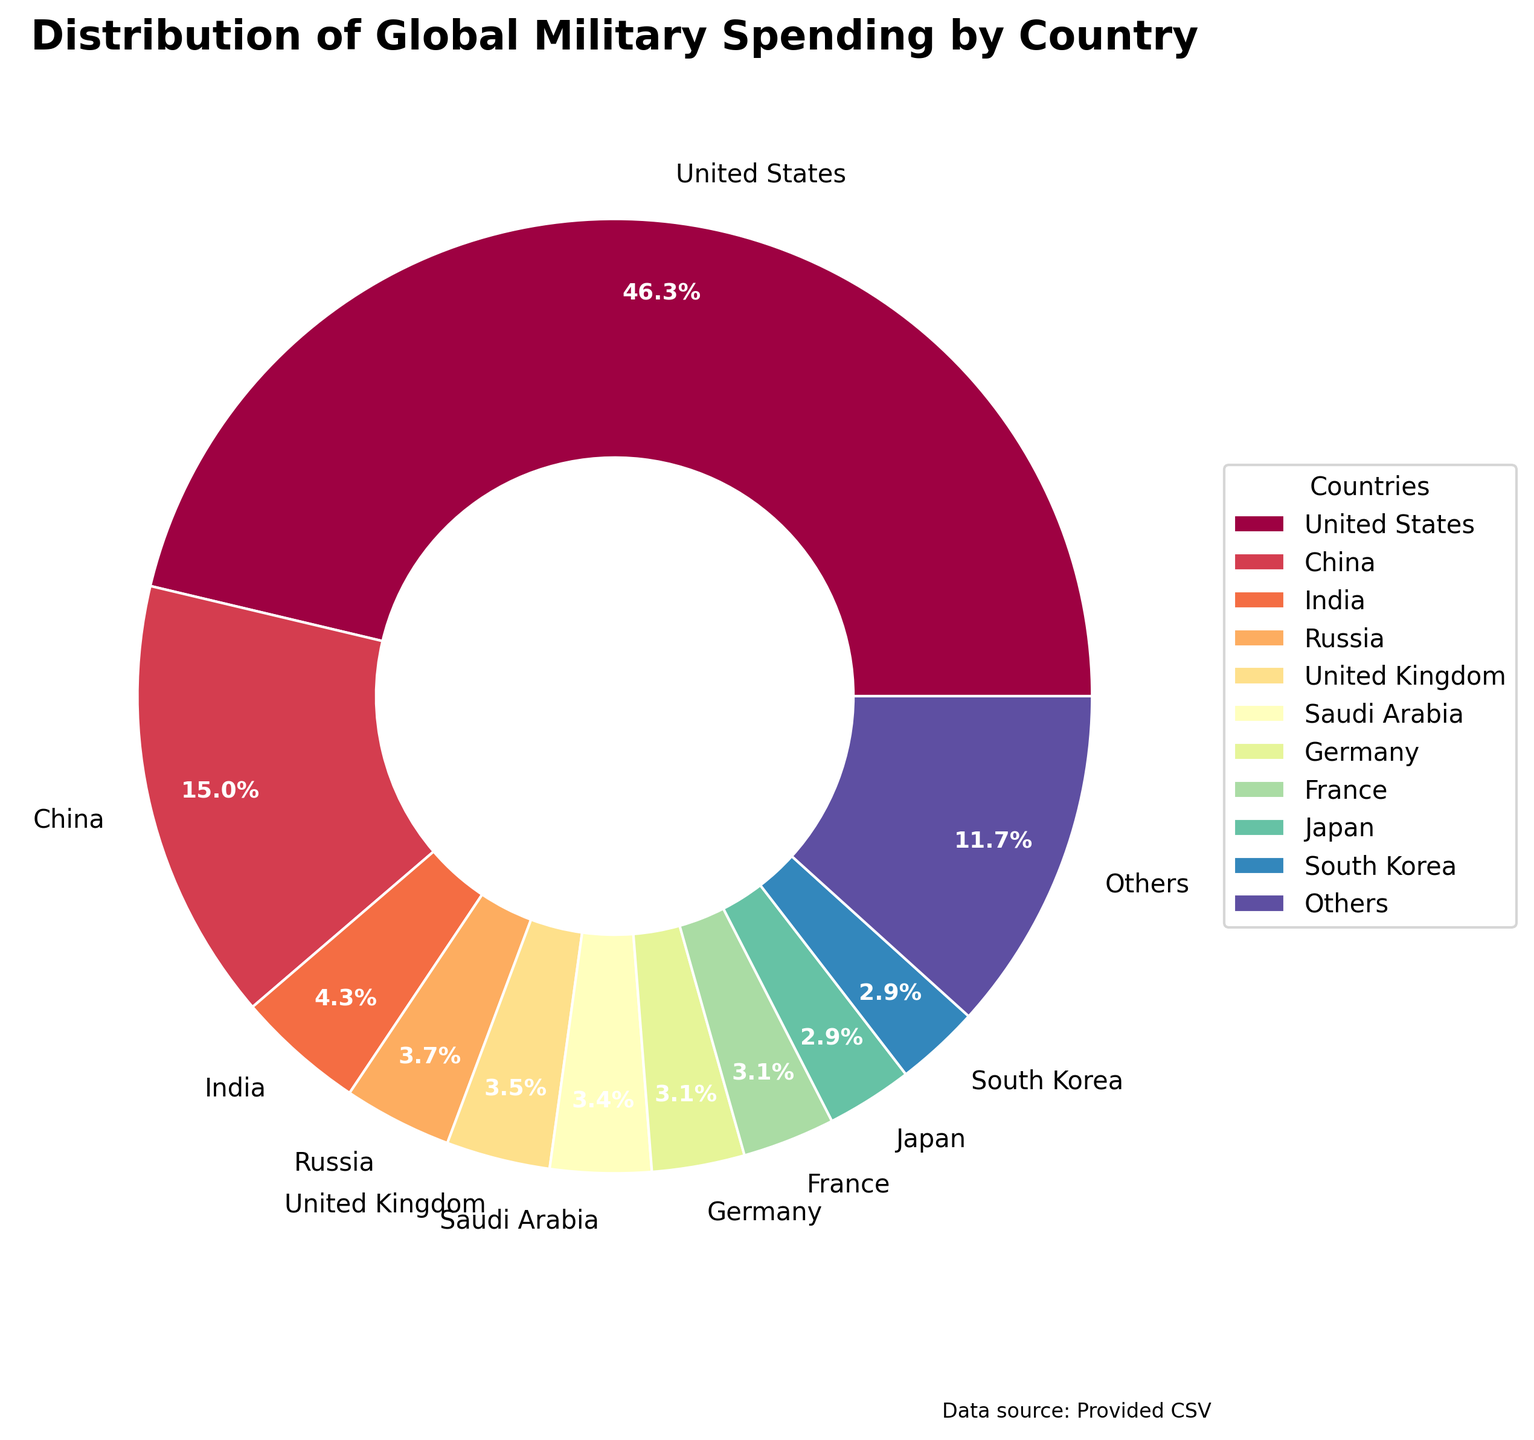Which country has the largest share of global military spending? The United States has the largest slice in the pie chart, with a percentage indicated that is higher than any other country.
Answer: United States Which countries are included in the "Others" category? The "Others" category represents the combined military spending of all countries listed from the 11th position onward, including Italy, Australia, Canada, Israel, Brazil, Turkey, Spain, Netherlands, Poland, and Taiwan.
Answer: Italy, Australia, Canada, Israel, Brazil, Turkey, Spain, Netherlands, Poland, Taiwan What percentage of global military spending is accounted for by the top 10 countries combined? Add the percentages of the top 10 countries from the chart, excluding "Others". The percentages are approximated as visually represented. For simplification, use the pie chart values.
Answer: roughly 80.0% How does China's military spending compare to Russia's? China's share is significantly larger than Russia's. By examining the chart, China's wedge appears substantially larger than Russia's, indicating China's spending percentage is higher.
Answer: China’s is higher What is the cumulative military spending of countries that fall under the "Others" category? According to the pie chart, the "Others" category is represented as approximately 13.4%. This includes the combined spending of all countries ranked 11th and below.
Answer: around $342.9 billion Which country spends more on military: Japan or South Korea? Japan and South Korea both appear on the chart, but Japan's wedge is slightly larger than South Korea’s, indicating that Japan's military spending is higher.
Answer: Japan What is the fourth highest military spending country? The chart orders countries by their spend from highest to lowest, showing the United States, China, India, and then Russia as the fourth.
Answer: Russia Is the military spending of the United States more than the combined spending of India and Russia? Compare the United States' segment with the combined segments of India and Russia. The United States’ segment is much larger than the combined segments of India ($72.9 billion) and Russia ($61.7 billion), summing to $134.6 billion.
Answer: Yes, it is more Can you find the total military spending of the top 3 countries? The top 3 countries by military spending are the United States ($778 billion), China ($252 billion), and India ($72.9 billion). Sum these values: 778 + 252 + 72.9 = 1102.9 billion USD.
Answer: 1102.9 billion USD 